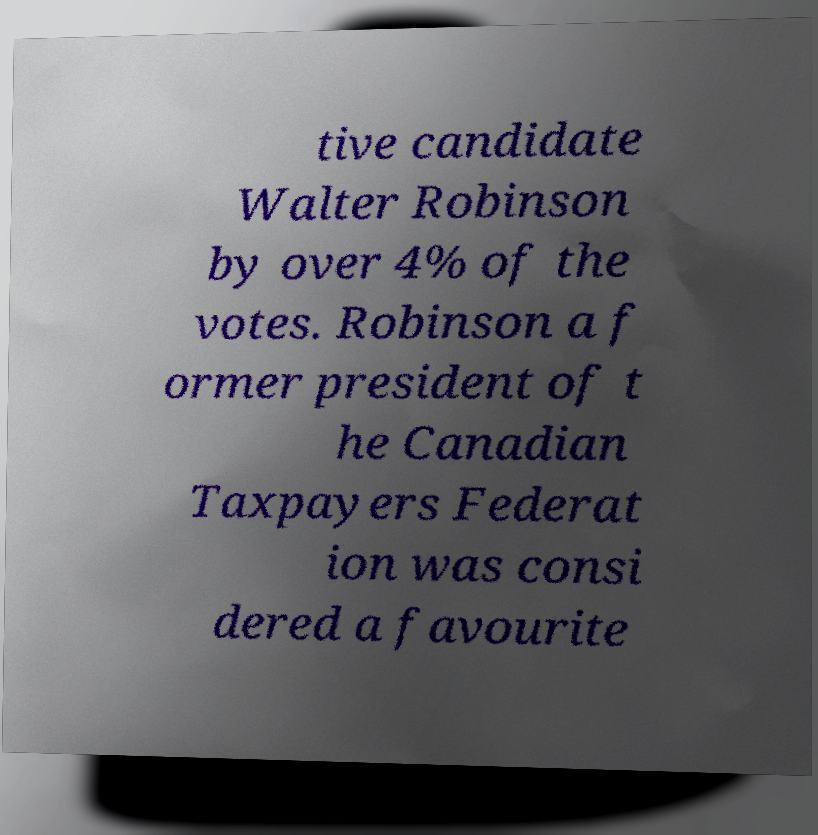Could you extract and type out the text from this image? tive candidate Walter Robinson by over 4% of the votes. Robinson a f ormer president of t he Canadian Taxpayers Federat ion was consi dered a favourite 